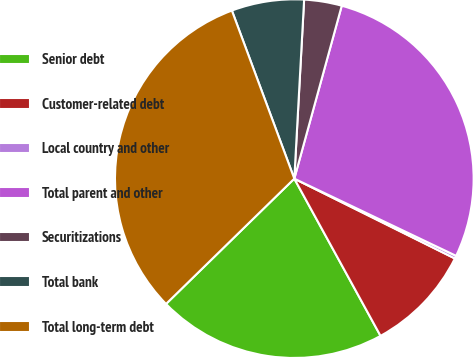Convert chart to OTSL. <chart><loc_0><loc_0><loc_500><loc_500><pie_chart><fcel>Senior debt<fcel>Customer-related debt<fcel>Local country and other<fcel>Total parent and other<fcel>Securitizations<fcel>Total bank<fcel>Total long-term debt<nl><fcel>20.67%<fcel>9.67%<fcel>0.26%<fcel>27.82%<fcel>3.39%<fcel>6.53%<fcel>31.65%<nl></chart> 